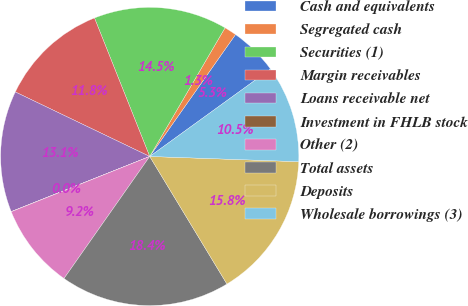Convert chart to OTSL. <chart><loc_0><loc_0><loc_500><loc_500><pie_chart><fcel>Cash and equivalents<fcel>Segregated cash<fcel>Securities (1)<fcel>Margin receivables<fcel>Loans receivable net<fcel>Investment in FHLB stock<fcel>Other (2)<fcel>Total assets<fcel>Deposits<fcel>Wholesale borrowings (3)<nl><fcel>5.27%<fcel>1.33%<fcel>14.47%<fcel>11.84%<fcel>13.15%<fcel>0.02%<fcel>9.21%<fcel>18.41%<fcel>15.78%<fcel>10.53%<nl></chart> 